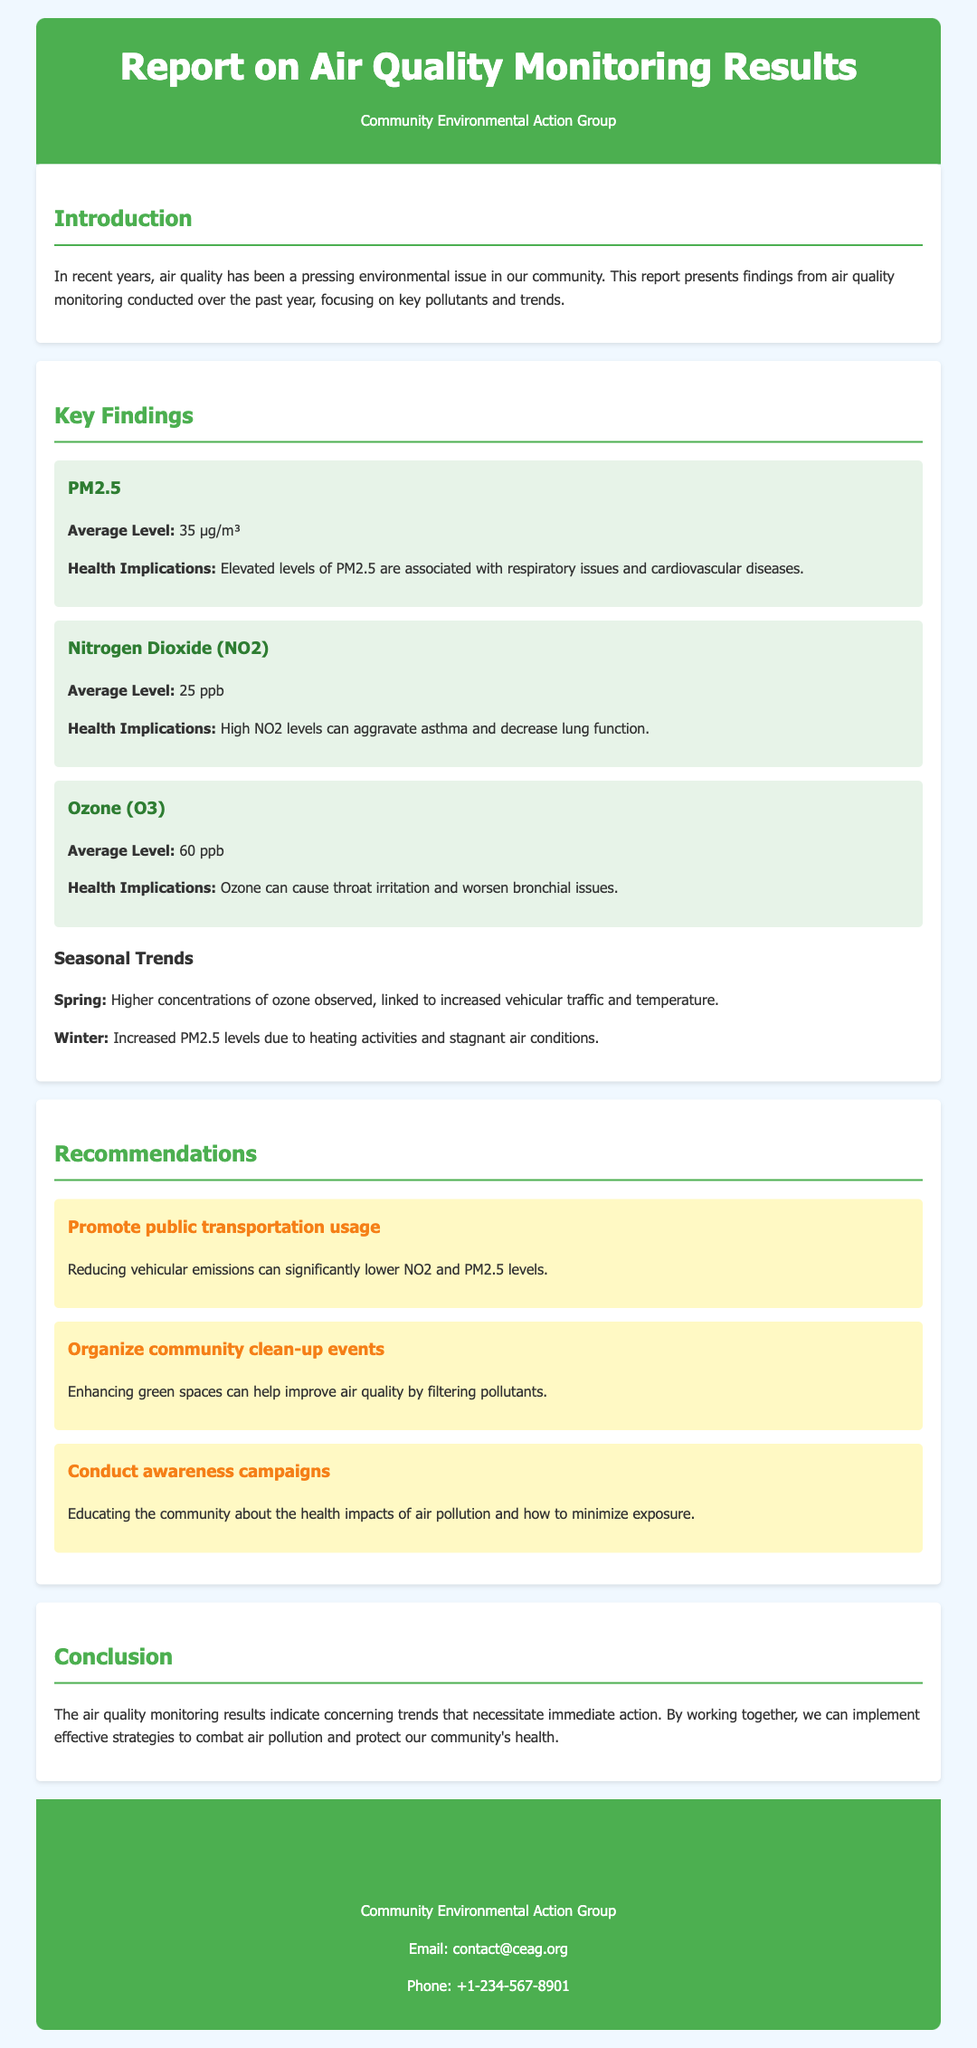What is the average level of PM2.5? The average level of PM2.5 is mentioned in the document as 35 µg/m³.
Answer: 35 µg/m³ What can high levels of NO2 aggravate? The document states that high NO2 levels can aggravate asthma.
Answer: Asthma During which season are higher concentrations of ozone observed? The report notes that higher concentrations of ozone are observed in spring.
Answer: Spring What is one recommendation for improving air quality? The document lists multiple recommendations, one of which is to promote public transportation usage.
Answer: Promote public transportation usage What health issues are associated with elevated levels of PM2.5? The health implications of elevated PM2.5 levels, as stated in the document, are respiratory issues and cardiovascular diseases.
Answer: Respiratory issues and cardiovascular diseases What organization created this report? The header indicates that the report was created by the Community Environmental Action Group.
Answer: Community Environmental Action Group What is recommended to organize for improving air quality? The document recommends organizing community clean-up events to enhance green spaces.
Answer: Community clean-up events What are the average levels of ozone mentioned in the report? The average level of ozone stated in the report is 60 ppb.
Answer: 60 ppb 